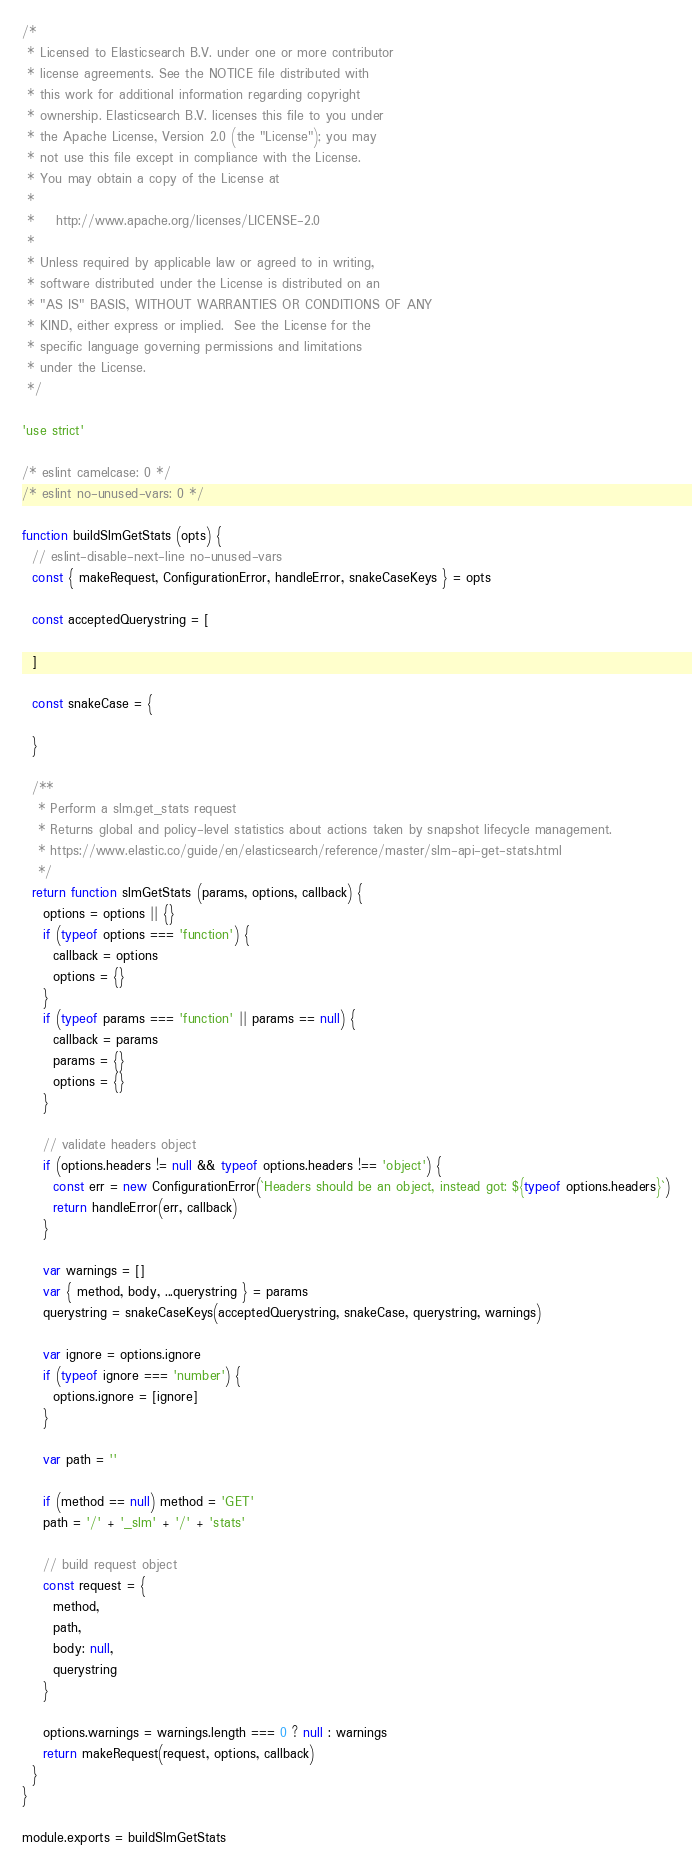<code> <loc_0><loc_0><loc_500><loc_500><_JavaScript_>/*
 * Licensed to Elasticsearch B.V. under one or more contributor
 * license agreements. See the NOTICE file distributed with
 * this work for additional information regarding copyright
 * ownership. Elasticsearch B.V. licenses this file to you under
 * the Apache License, Version 2.0 (the "License"); you may
 * not use this file except in compliance with the License.
 * You may obtain a copy of the License at
 *
 *    http://www.apache.org/licenses/LICENSE-2.0
 *
 * Unless required by applicable law or agreed to in writing,
 * software distributed under the License is distributed on an
 * "AS IS" BASIS, WITHOUT WARRANTIES OR CONDITIONS OF ANY
 * KIND, either express or implied.  See the License for the
 * specific language governing permissions and limitations
 * under the License.
 */

'use strict'

/* eslint camelcase: 0 */
/* eslint no-unused-vars: 0 */

function buildSlmGetStats (opts) {
  // eslint-disable-next-line no-unused-vars
  const { makeRequest, ConfigurationError, handleError, snakeCaseKeys } = opts

  const acceptedQuerystring = [

  ]

  const snakeCase = {

  }

  /**
   * Perform a slm.get_stats request
   * Returns global and policy-level statistics about actions taken by snapshot lifecycle management.
   * https://www.elastic.co/guide/en/elasticsearch/reference/master/slm-api-get-stats.html
   */
  return function slmGetStats (params, options, callback) {
    options = options || {}
    if (typeof options === 'function') {
      callback = options
      options = {}
    }
    if (typeof params === 'function' || params == null) {
      callback = params
      params = {}
      options = {}
    }

    // validate headers object
    if (options.headers != null && typeof options.headers !== 'object') {
      const err = new ConfigurationError(`Headers should be an object, instead got: ${typeof options.headers}`)
      return handleError(err, callback)
    }

    var warnings = []
    var { method, body, ...querystring } = params
    querystring = snakeCaseKeys(acceptedQuerystring, snakeCase, querystring, warnings)

    var ignore = options.ignore
    if (typeof ignore === 'number') {
      options.ignore = [ignore]
    }

    var path = ''

    if (method == null) method = 'GET'
    path = '/' + '_slm' + '/' + 'stats'

    // build request object
    const request = {
      method,
      path,
      body: null,
      querystring
    }

    options.warnings = warnings.length === 0 ? null : warnings
    return makeRequest(request, options, callback)
  }
}

module.exports = buildSlmGetStats
</code> 